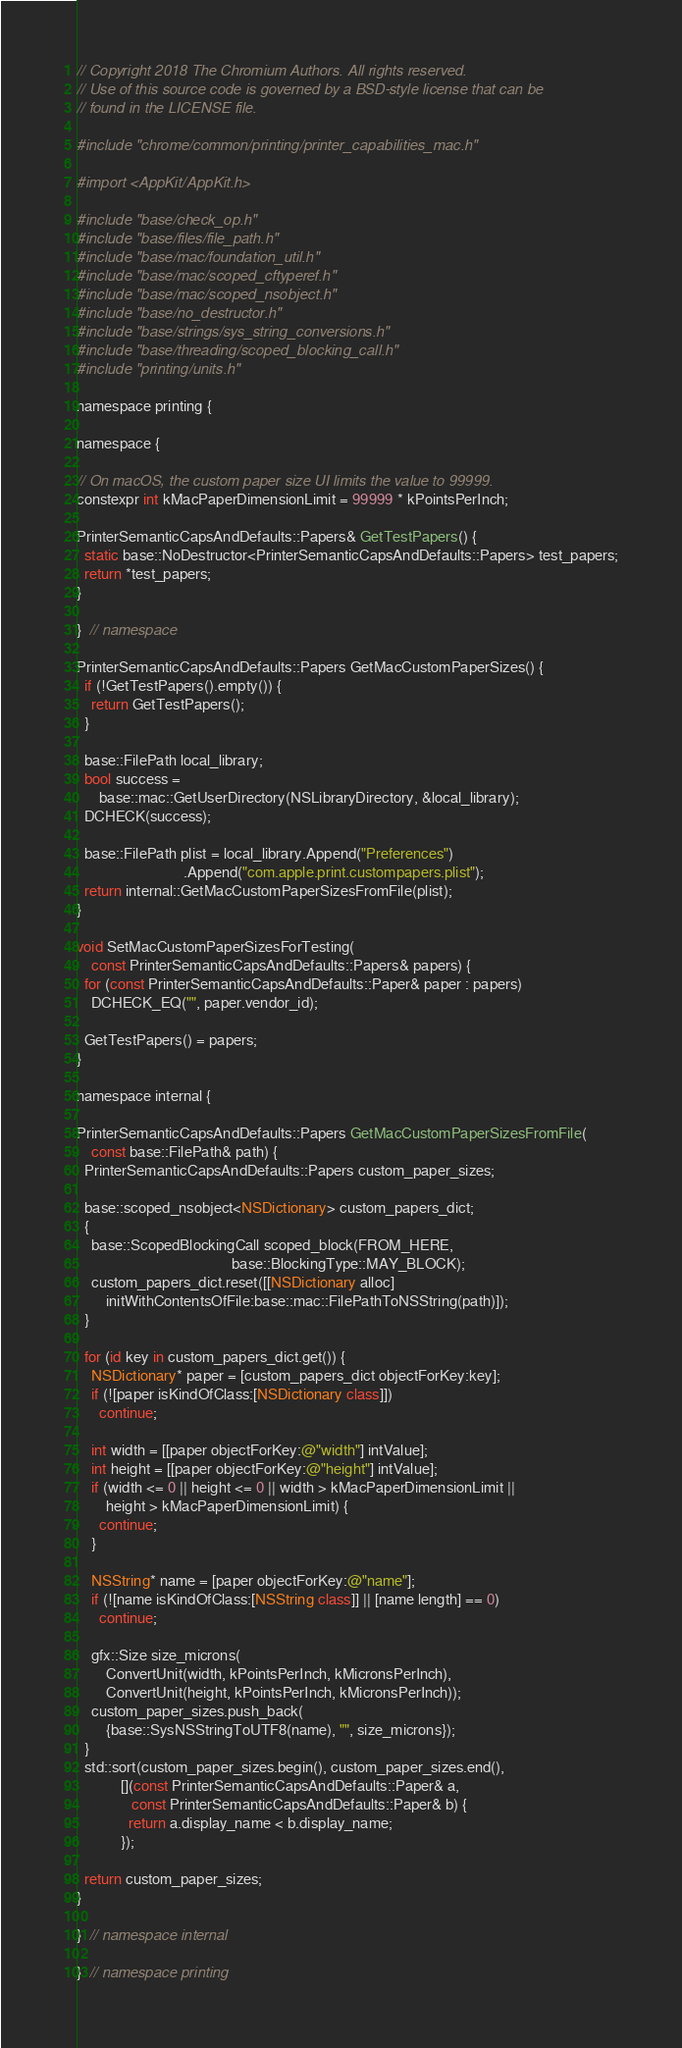Convert code to text. <code><loc_0><loc_0><loc_500><loc_500><_ObjectiveC_>// Copyright 2018 The Chromium Authors. All rights reserved.
// Use of this source code is governed by a BSD-style license that can be
// found in the LICENSE file.

#include "chrome/common/printing/printer_capabilities_mac.h"

#import <AppKit/AppKit.h>

#include "base/check_op.h"
#include "base/files/file_path.h"
#include "base/mac/foundation_util.h"
#include "base/mac/scoped_cftyperef.h"
#include "base/mac/scoped_nsobject.h"
#include "base/no_destructor.h"
#include "base/strings/sys_string_conversions.h"
#include "base/threading/scoped_blocking_call.h"
#include "printing/units.h"

namespace printing {

namespace {

// On macOS, the custom paper size UI limits the value to 99999.
constexpr int kMacPaperDimensionLimit = 99999 * kPointsPerInch;

PrinterSemanticCapsAndDefaults::Papers& GetTestPapers() {
  static base::NoDestructor<PrinterSemanticCapsAndDefaults::Papers> test_papers;
  return *test_papers;
}

}  // namespace

PrinterSemanticCapsAndDefaults::Papers GetMacCustomPaperSizes() {
  if (!GetTestPapers().empty()) {
    return GetTestPapers();
  }

  base::FilePath local_library;
  bool success =
      base::mac::GetUserDirectory(NSLibraryDirectory, &local_library);
  DCHECK(success);

  base::FilePath plist = local_library.Append("Preferences")
                             .Append("com.apple.print.custompapers.plist");
  return internal::GetMacCustomPaperSizesFromFile(plist);
}

void SetMacCustomPaperSizesForTesting(
    const PrinterSemanticCapsAndDefaults::Papers& papers) {
  for (const PrinterSemanticCapsAndDefaults::Paper& paper : papers)
    DCHECK_EQ("", paper.vendor_id);

  GetTestPapers() = papers;
}

namespace internal {

PrinterSemanticCapsAndDefaults::Papers GetMacCustomPaperSizesFromFile(
    const base::FilePath& path) {
  PrinterSemanticCapsAndDefaults::Papers custom_paper_sizes;

  base::scoped_nsobject<NSDictionary> custom_papers_dict;
  {
    base::ScopedBlockingCall scoped_block(FROM_HERE,
                                          base::BlockingType::MAY_BLOCK);
    custom_papers_dict.reset([[NSDictionary alloc]
        initWithContentsOfFile:base::mac::FilePathToNSString(path)]);
  }

  for (id key in custom_papers_dict.get()) {
    NSDictionary* paper = [custom_papers_dict objectForKey:key];
    if (![paper isKindOfClass:[NSDictionary class]])
      continue;

    int width = [[paper objectForKey:@"width"] intValue];
    int height = [[paper objectForKey:@"height"] intValue];
    if (width <= 0 || height <= 0 || width > kMacPaperDimensionLimit ||
        height > kMacPaperDimensionLimit) {
      continue;
    }

    NSString* name = [paper objectForKey:@"name"];
    if (![name isKindOfClass:[NSString class]] || [name length] == 0)
      continue;

    gfx::Size size_microns(
        ConvertUnit(width, kPointsPerInch, kMicronsPerInch),
        ConvertUnit(height, kPointsPerInch, kMicronsPerInch));
    custom_paper_sizes.push_back(
        {base::SysNSStringToUTF8(name), "", size_microns});
  }
  std::sort(custom_paper_sizes.begin(), custom_paper_sizes.end(),
            [](const PrinterSemanticCapsAndDefaults::Paper& a,
               const PrinterSemanticCapsAndDefaults::Paper& b) {
              return a.display_name < b.display_name;
            });

  return custom_paper_sizes;
}

}  // namespace internal

}  // namespace printing
</code> 